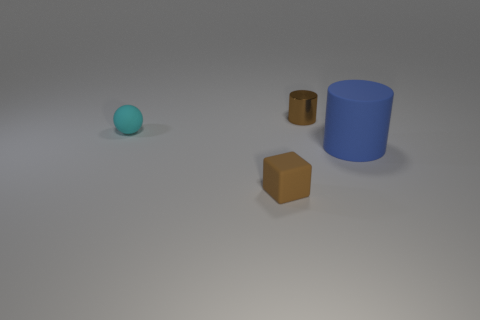Add 1 red matte spheres. How many objects exist? 5 Subtract all spheres. How many objects are left? 3 Add 4 tiny metallic cylinders. How many tiny metallic cylinders are left? 5 Add 3 small brown rubber blocks. How many small brown rubber blocks exist? 4 Subtract 1 blue cylinders. How many objects are left? 3 Subtract all blue cylinders. Subtract all large purple shiny cubes. How many objects are left? 3 